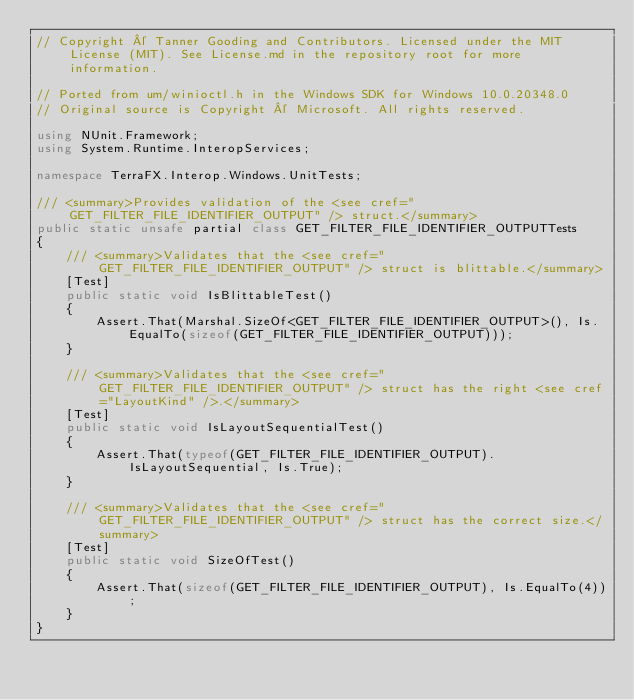Convert code to text. <code><loc_0><loc_0><loc_500><loc_500><_C#_>// Copyright © Tanner Gooding and Contributors. Licensed under the MIT License (MIT). See License.md in the repository root for more information.

// Ported from um/winioctl.h in the Windows SDK for Windows 10.0.20348.0
// Original source is Copyright © Microsoft. All rights reserved.

using NUnit.Framework;
using System.Runtime.InteropServices;

namespace TerraFX.Interop.Windows.UnitTests;

/// <summary>Provides validation of the <see cref="GET_FILTER_FILE_IDENTIFIER_OUTPUT" /> struct.</summary>
public static unsafe partial class GET_FILTER_FILE_IDENTIFIER_OUTPUTTests
{
    /// <summary>Validates that the <see cref="GET_FILTER_FILE_IDENTIFIER_OUTPUT" /> struct is blittable.</summary>
    [Test]
    public static void IsBlittableTest()
    {
        Assert.That(Marshal.SizeOf<GET_FILTER_FILE_IDENTIFIER_OUTPUT>(), Is.EqualTo(sizeof(GET_FILTER_FILE_IDENTIFIER_OUTPUT)));
    }

    /// <summary>Validates that the <see cref="GET_FILTER_FILE_IDENTIFIER_OUTPUT" /> struct has the right <see cref="LayoutKind" />.</summary>
    [Test]
    public static void IsLayoutSequentialTest()
    {
        Assert.That(typeof(GET_FILTER_FILE_IDENTIFIER_OUTPUT).IsLayoutSequential, Is.True);
    }

    /// <summary>Validates that the <see cref="GET_FILTER_FILE_IDENTIFIER_OUTPUT" /> struct has the correct size.</summary>
    [Test]
    public static void SizeOfTest()
    {
        Assert.That(sizeof(GET_FILTER_FILE_IDENTIFIER_OUTPUT), Is.EqualTo(4));
    }
}
</code> 